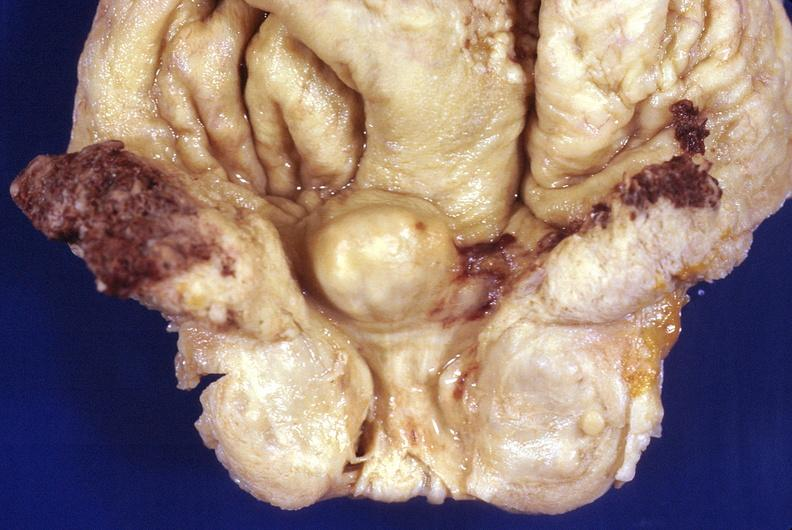where is this?
Answer the question using a single word or phrase. Urinary 